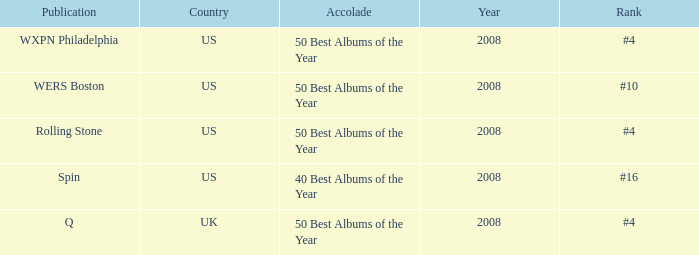When was the united states ranked #4 in a specific year? 2008, 2008. 